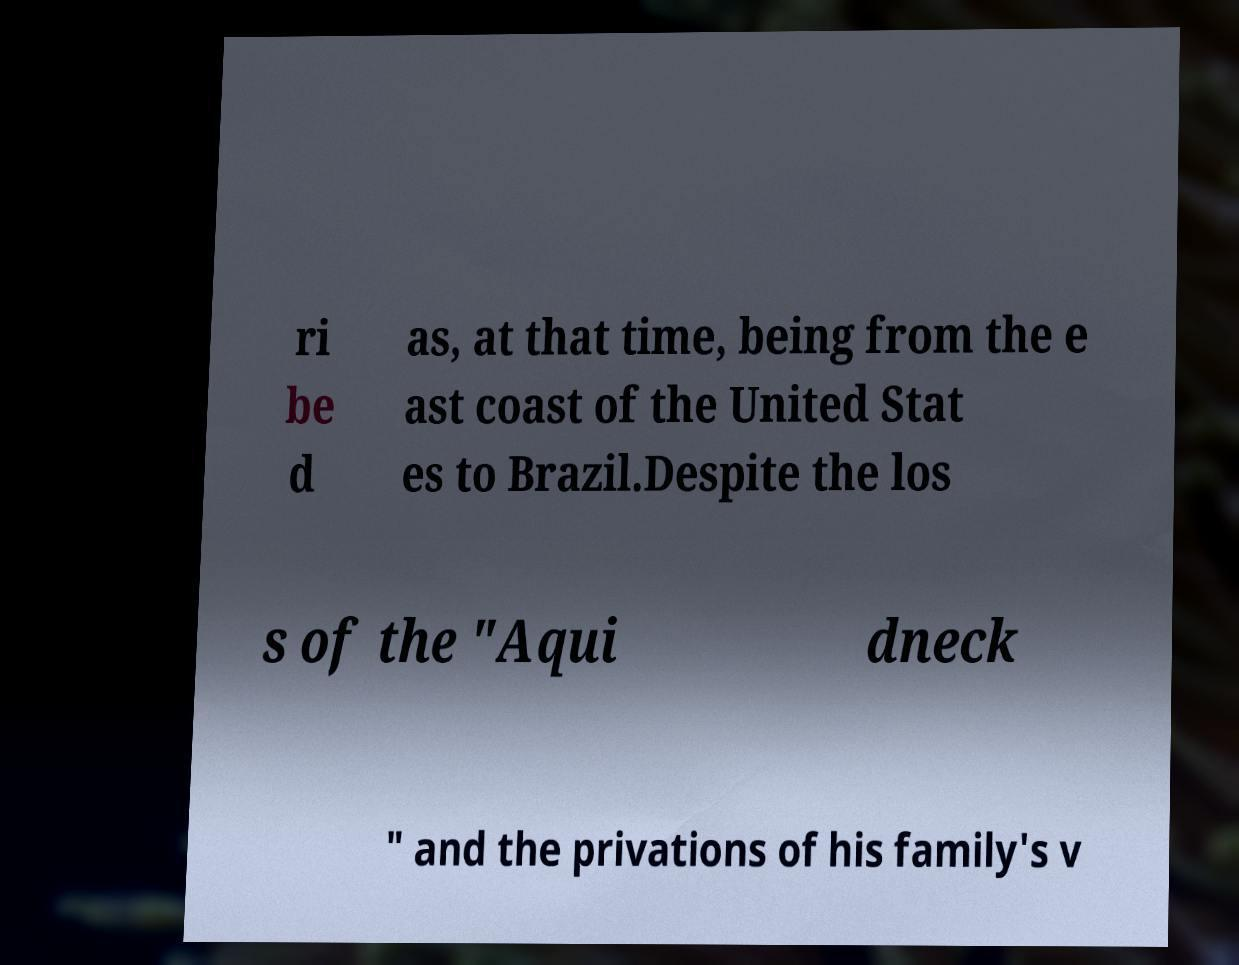What messages or text are displayed in this image? I need them in a readable, typed format. ri be d as, at that time, being from the e ast coast of the United Stat es to Brazil.Despite the los s of the "Aqui dneck " and the privations of his family's v 